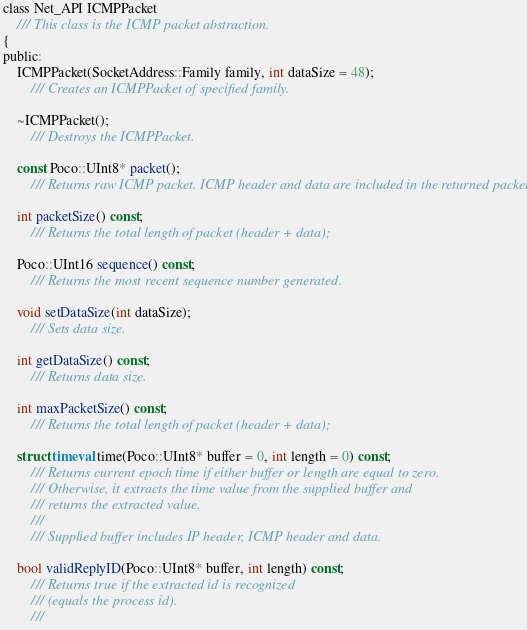Convert code to text. <code><loc_0><loc_0><loc_500><loc_500><_C_>class Net_API ICMPPacket
	/// This class is the ICMP packet abstraction. 
{
public:
	ICMPPacket(SocketAddress::Family family, int dataSize = 48);
		/// Creates an ICMPPacket of specified family.

	~ICMPPacket();
		/// Destroys the ICMPPacket.

	const Poco::UInt8* packet();
		/// Returns raw ICMP packet. ICMP header and data are included in the returned packet.

	int packetSize() const;
		/// Returns the total length of packet (header + data);

	Poco::UInt16 sequence() const;
		/// Returns the most recent sequence number generated.

	void setDataSize(int dataSize);
		/// Sets data size.

	int getDataSize() const;
		/// Returns data size.

	int maxPacketSize() const;
		/// Returns the total length of packet (header + data);

	struct timeval time(Poco::UInt8* buffer = 0, int length = 0) const;
		/// Returns current epoch time if either buffer or length are equal to zero.
		/// Otherwise, it extracts the time value from the supplied buffer and 
		/// returns the extracted value.
		/// 
		/// Supplied buffer includes IP header, ICMP header and data.

	bool validReplyID(Poco::UInt8* buffer, int length) const;
		/// Returns true if the extracted id is recognized 
		/// (equals the process id).
		///	</code> 